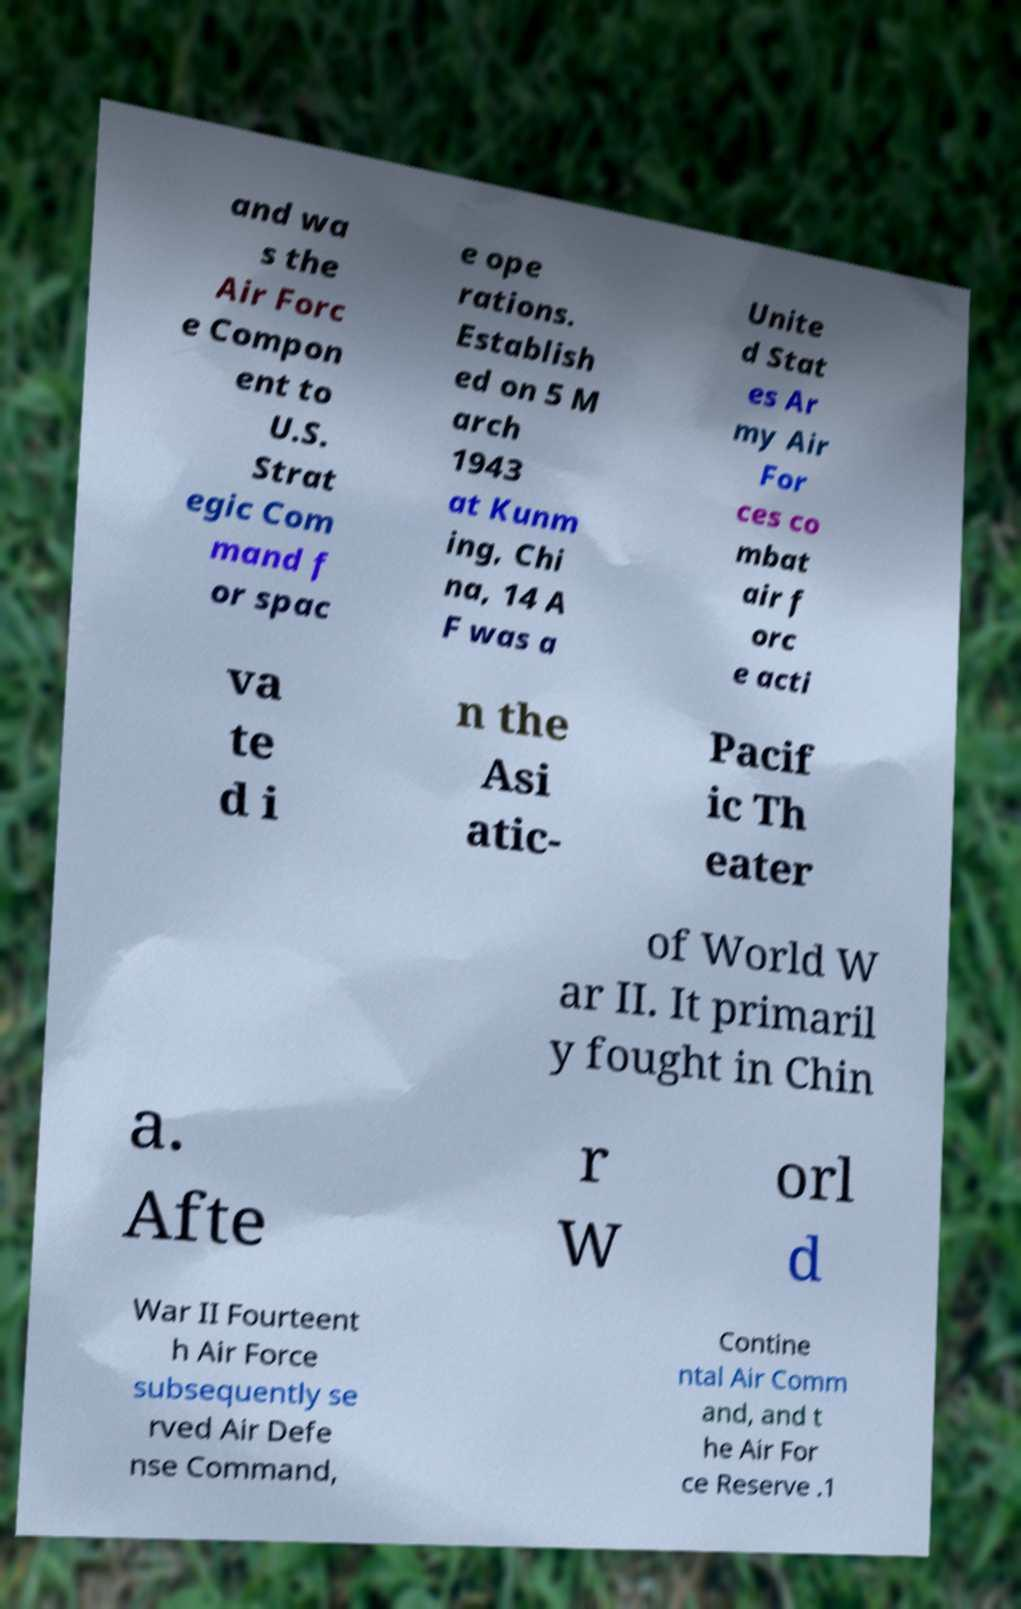Please read and relay the text visible in this image. What does it say? and wa s the Air Forc e Compon ent to U.S. Strat egic Com mand f or spac e ope rations. Establish ed on 5 M arch 1943 at Kunm ing, Chi na, 14 A F was a Unite d Stat es Ar my Air For ces co mbat air f orc e acti va te d i n the Asi atic- Pacif ic Th eater of World W ar II. It primaril y fought in Chin a. Afte r W orl d War II Fourteent h Air Force subsequently se rved Air Defe nse Command, Contine ntal Air Comm and, and t he Air For ce Reserve .1 